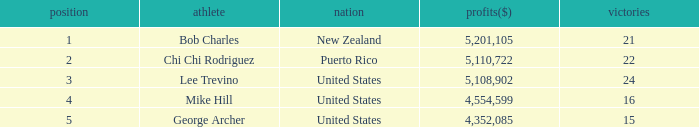In total, how much did the United States player George Archer earn with Wins lower than 24 and a rank that was higher than 5? 0.0. Would you mind parsing the complete table? {'header': ['position', 'athlete', 'nation', 'profits($)', 'victories'], 'rows': [['1', 'Bob Charles', 'New Zealand', '5,201,105', '21'], ['2', 'Chi Chi Rodriguez', 'Puerto Rico', '5,110,722', '22'], ['3', 'Lee Trevino', 'United States', '5,108,902', '24'], ['4', 'Mike Hill', 'United States', '4,554,599', '16'], ['5', 'George Archer', 'United States', '4,352,085', '15']]} 